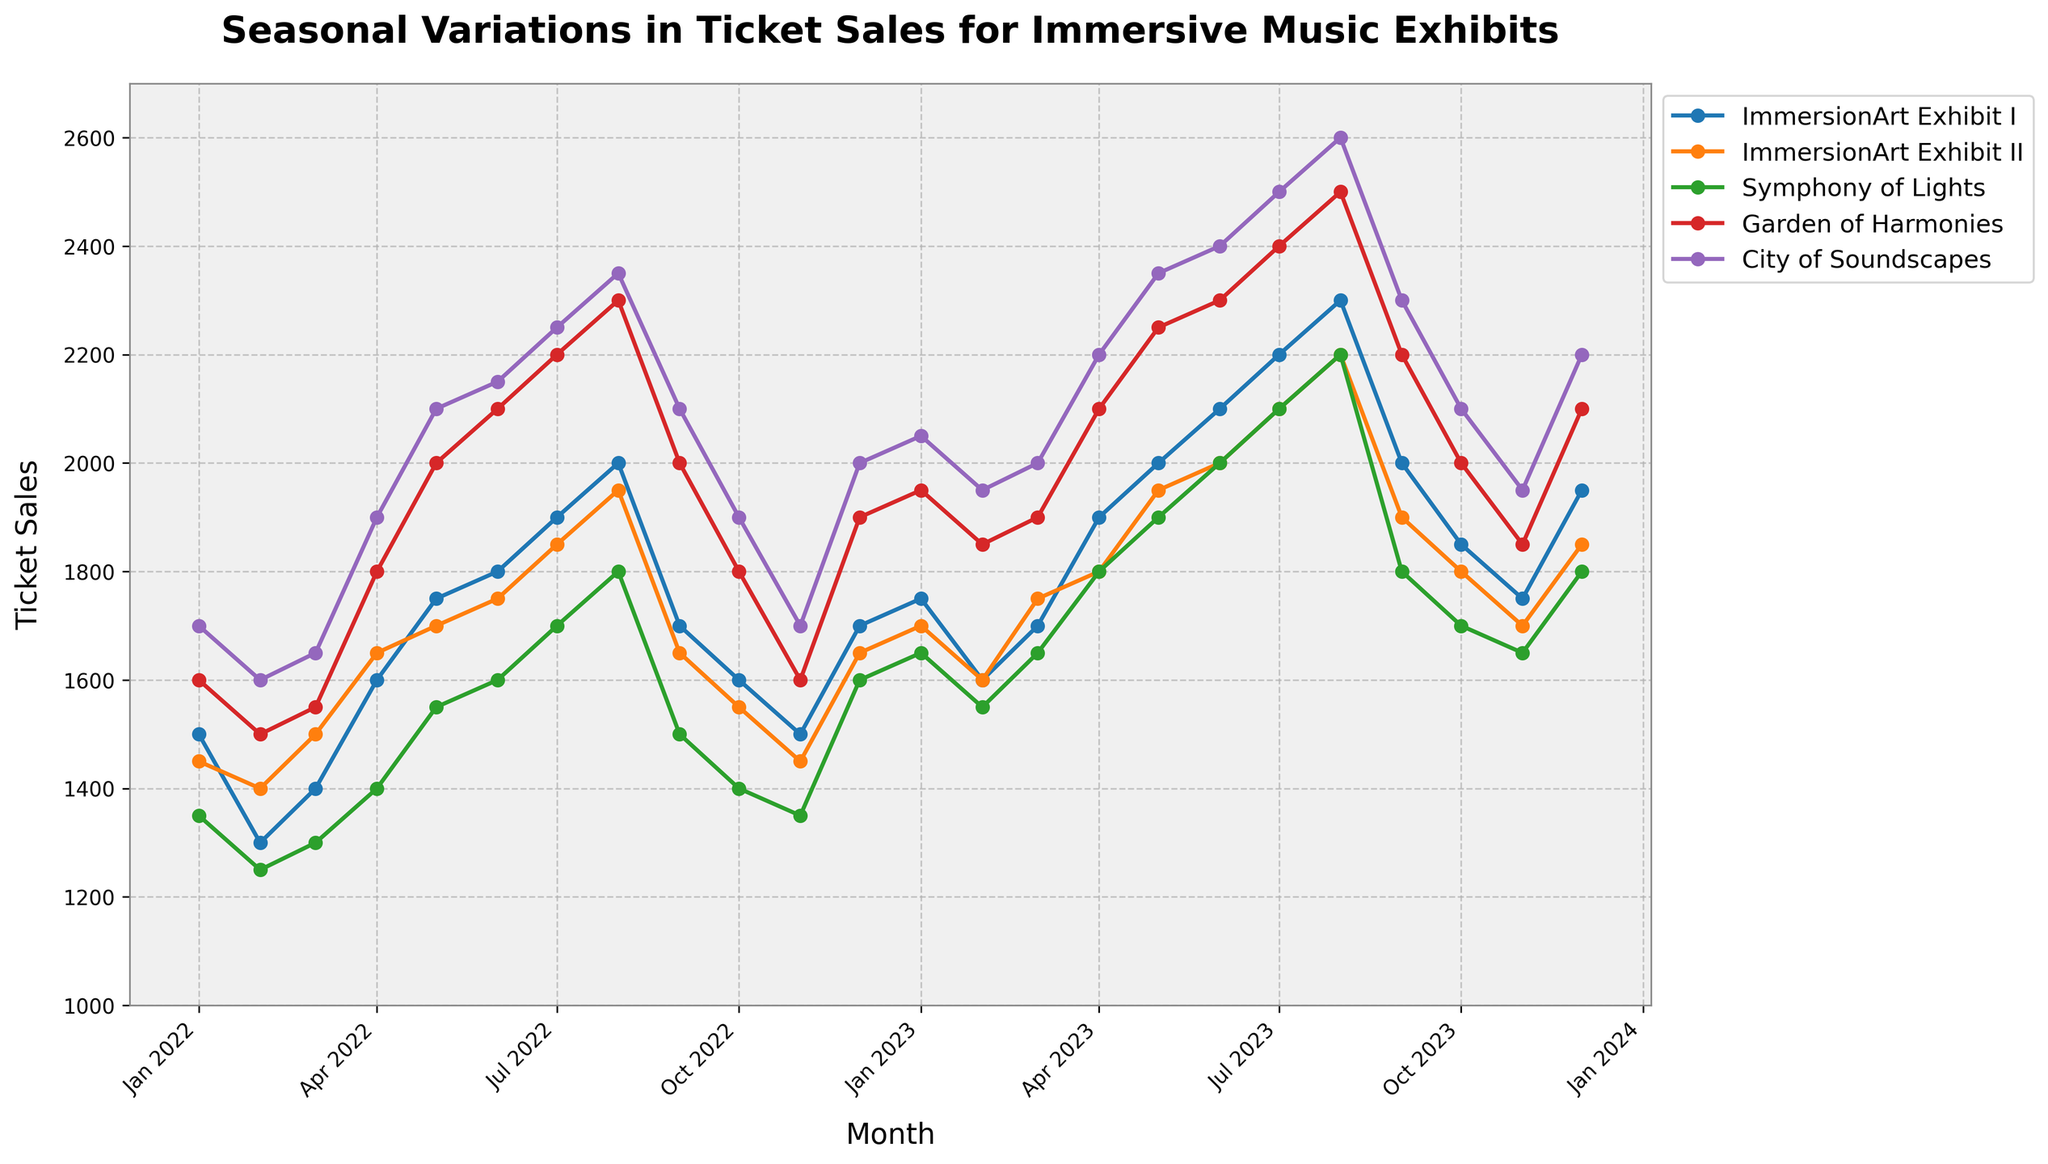What is the title of the plot? The title of the plot is usually located at the top of the figure. In this case, the title is "Seasonal Variations in Ticket Sales for Immersive Music Exhibits".
Answer: Seasonal Variations in Ticket Sales for Immersive Music Exhibits How are the y-axis limits set in the plot? The y-axis limits refer to the range of values displayed on the vertical axis. In this plot, the y-axis starts at 1000 and goes up to 2700.
Answer: 1000 to 2700 What month displayed the highest ticket sales for the "Garden of Harmonies"? To find the highest ticket sales for the "Garden of Harmonies", identify the peak point on its line. This occurs in August 2023 where the sales reach 2500 tickets.
Answer: August 2023 Which exhibit had the lowest ticket sales in February 2022? Look at the points for February 2022 and compare the ticket sales across exhibits. "Symphony of Lights" had the lowest tickets at 1250.
Answer: Symphony of Lights What is the trend observed for "City of Soundscapes" from January 2022 to August 2023? To identify the trend, observe the points for "City of Soundscapes" across time. The line shows an overall increasing trend up to August 2023, peaking at 2600 tickets.
Answer: Increasing trend Between which months do we see a significant drop in ticket sales for "ImmersionArt Exhibit I"? Analyze the points for "ImmersionArt Exhibit I". A significant drop can be seen from August 2023 (2300) to September 2023 (2000), a reduction of 300 tickets.
Answer: August 2023 to September 2023 How did ticket sales for "Symphony of Lights" change between July 2022 and July 2023? Compare the ticket sales for "Symphony of Lights" in July of both years. July 2022 had 1700 tickets, while July 2023 had 2100, indicating an increase.
Answer: Increased What is the average ticket sales for "ImmersionArt Exhibit II" in 2022? To calculate the average, sum the monthly ticket sales for "ImmersionArt Exhibit II" in 2022 and divide by 12. Sum is 19550 and average is 19550/12 = 1629.17.
Answer: 1629.17 Which exhibit shows the least fluctuation in ticket sales over the displayed period? To determine fluctuation, observe the range of ticket sales for each exhibit. "Symphony of Lights" has the smallest range, from 1250 to 2200, showing least fluctuation.
Answer: Symphony of Lights How do ticket sales for "Symphony of Lights" in December compare between 2022 and 2023? Compare the ticket sales for "Symphony of Lights" in December 2022 and December 2023. December 2022 had 1600 tickets, while December 2023 had 1800, thus increasing by 200 tickets.
Answer: Increased by 200 